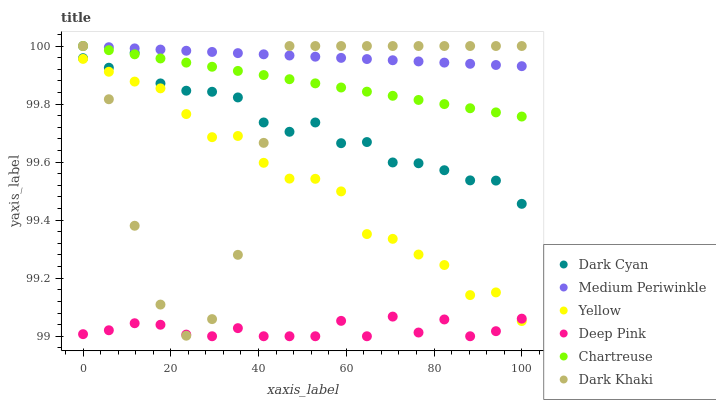Does Deep Pink have the minimum area under the curve?
Answer yes or no. Yes. Does Medium Periwinkle have the maximum area under the curve?
Answer yes or no. Yes. Does Yellow have the minimum area under the curve?
Answer yes or no. No. Does Yellow have the maximum area under the curve?
Answer yes or no. No. Is Medium Periwinkle the smoothest?
Answer yes or no. Yes. Is Dark Khaki the roughest?
Answer yes or no. Yes. Is Yellow the smoothest?
Answer yes or no. No. Is Yellow the roughest?
Answer yes or no. No. Does Deep Pink have the lowest value?
Answer yes or no. Yes. Does Yellow have the lowest value?
Answer yes or no. No. Does Chartreuse have the highest value?
Answer yes or no. Yes. Does Yellow have the highest value?
Answer yes or no. No. Is Deep Pink less than Medium Periwinkle?
Answer yes or no. Yes. Is Chartreuse greater than Deep Pink?
Answer yes or no. Yes. Does Chartreuse intersect Dark Khaki?
Answer yes or no. Yes. Is Chartreuse less than Dark Khaki?
Answer yes or no. No. Is Chartreuse greater than Dark Khaki?
Answer yes or no. No. Does Deep Pink intersect Medium Periwinkle?
Answer yes or no. No. 